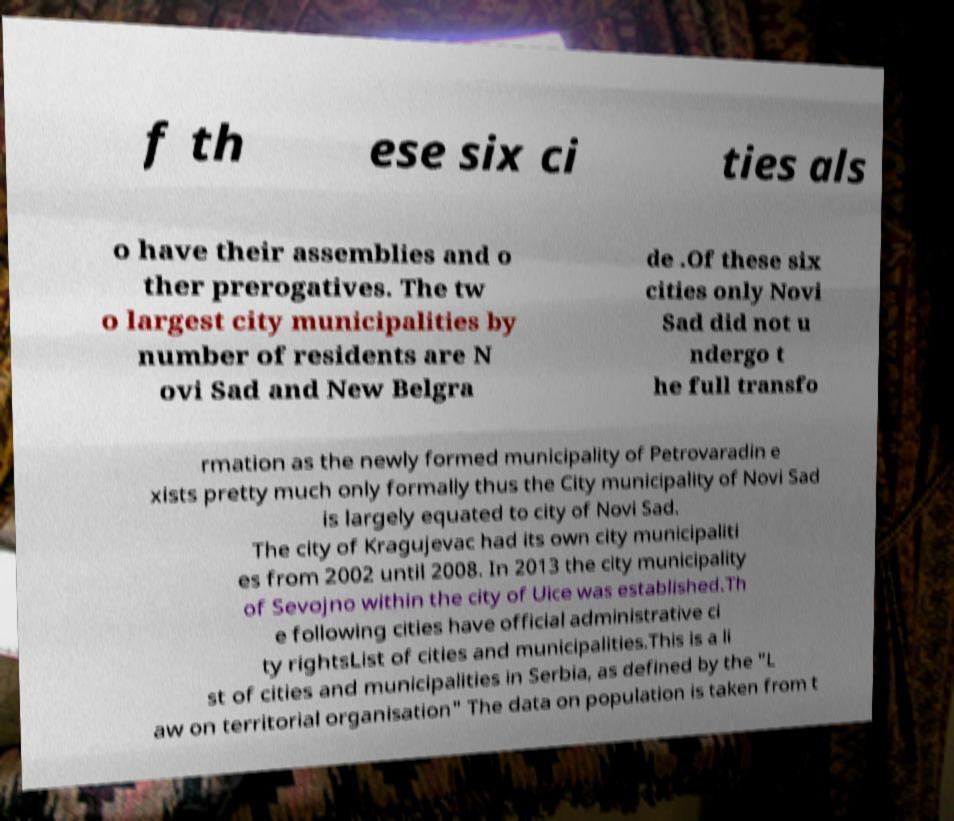Could you assist in decoding the text presented in this image and type it out clearly? f th ese six ci ties als o have their assemblies and o ther prerogatives. The tw o largest city municipalities by number of residents are N ovi Sad and New Belgra de .Of these six cities only Novi Sad did not u ndergo t he full transfo rmation as the newly formed municipality of Petrovaradin e xists pretty much only formally thus the City municipality of Novi Sad is largely equated to city of Novi Sad. The city of Kragujevac had its own city municipaliti es from 2002 until 2008. In 2013 the city municipality of Sevojno within the city of Uice was established.Th e following cities have official administrative ci ty rightsList of cities and municipalities.This is a li st of cities and municipalities in Serbia, as defined by the "L aw on territorial organisation" The data on population is taken from t 